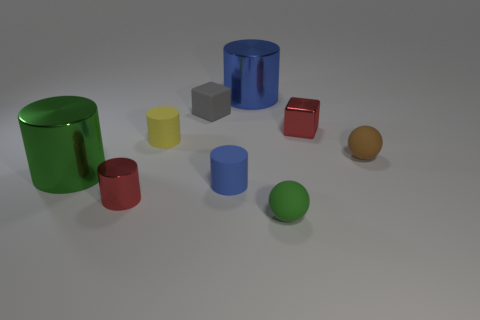There is a blue metal thing that is the same size as the green cylinder; what is its shape?
Your response must be concise. Cylinder. Is there another small yellow object that has the same shape as the tiny yellow matte object?
Provide a succinct answer. No. How many cubes have the same material as the tiny yellow cylinder?
Give a very brief answer. 1. Does the tiny cylinder that is left of the tiny yellow object have the same material as the tiny green sphere?
Offer a terse response. No. Is the number of small metallic cylinders that are left of the green shiny cylinder greater than the number of green matte objects that are behind the small shiny cylinder?
Your response must be concise. No. There is a blue cylinder that is the same size as the green sphere; what material is it?
Make the answer very short. Rubber. What number of other things are the same material as the yellow cylinder?
Make the answer very short. 4. Is the shape of the green thing that is to the left of the yellow matte thing the same as the small rubber object that is left of the gray cube?
Keep it short and to the point. Yes. What number of other objects are there of the same color as the matte block?
Keep it short and to the point. 0. Does the tiny red thing that is on the right side of the yellow matte object have the same material as the large cylinder that is to the left of the red shiny cylinder?
Your answer should be compact. Yes. 